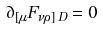<formula> <loc_0><loc_0><loc_500><loc_500>\partial _ { [ \mu } F _ { \nu \rho ] \, D } = 0</formula> 